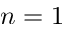Convert formula to latex. <formula><loc_0><loc_0><loc_500><loc_500>n = 1</formula> 